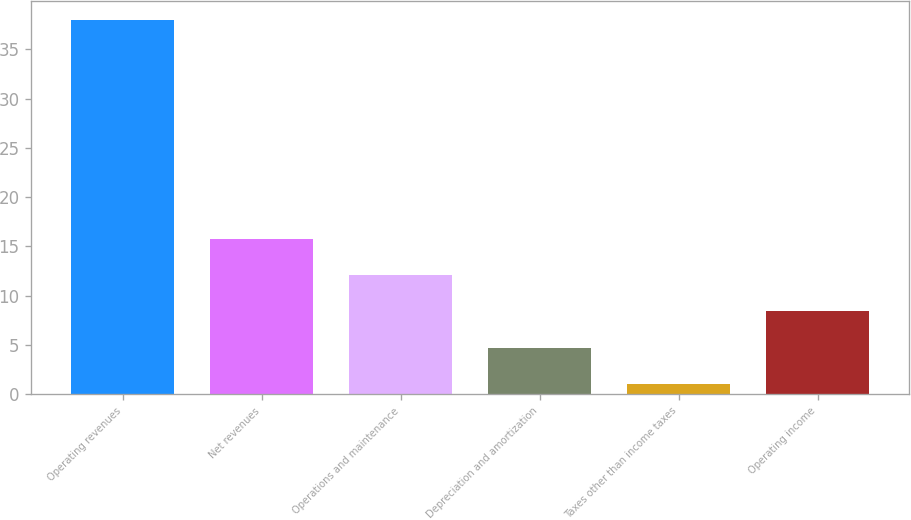Convert chart. <chart><loc_0><loc_0><loc_500><loc_500><bar_chart><fcel>Operating revenues<fcel>Net revenues<fcel>Operations and maintenance<fcel>Depreciation and amortization<fcel>Taxes other than income taxes<fcel>Operating income<nl><fcel>38<fcel>15.8<fcel>12.1<fcel>4.7<fcel>1<fcel>8.4<nl></chart> 